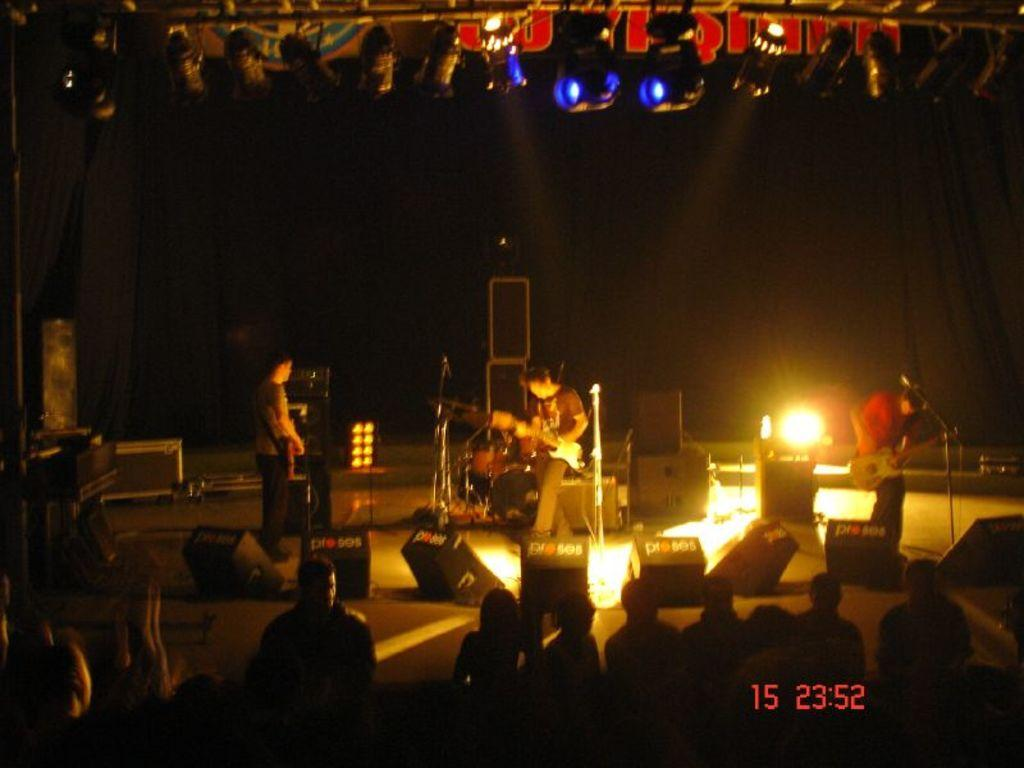What are the people on the stage doing? The people on the stage are playing musical instruments. What are the people in the audience doing? The people in the audience are sitting and watching the performance. What is the opinion of the needle on the health of the audience? There is no needle present in the image, and therefore no opinion can be attributed to it. 